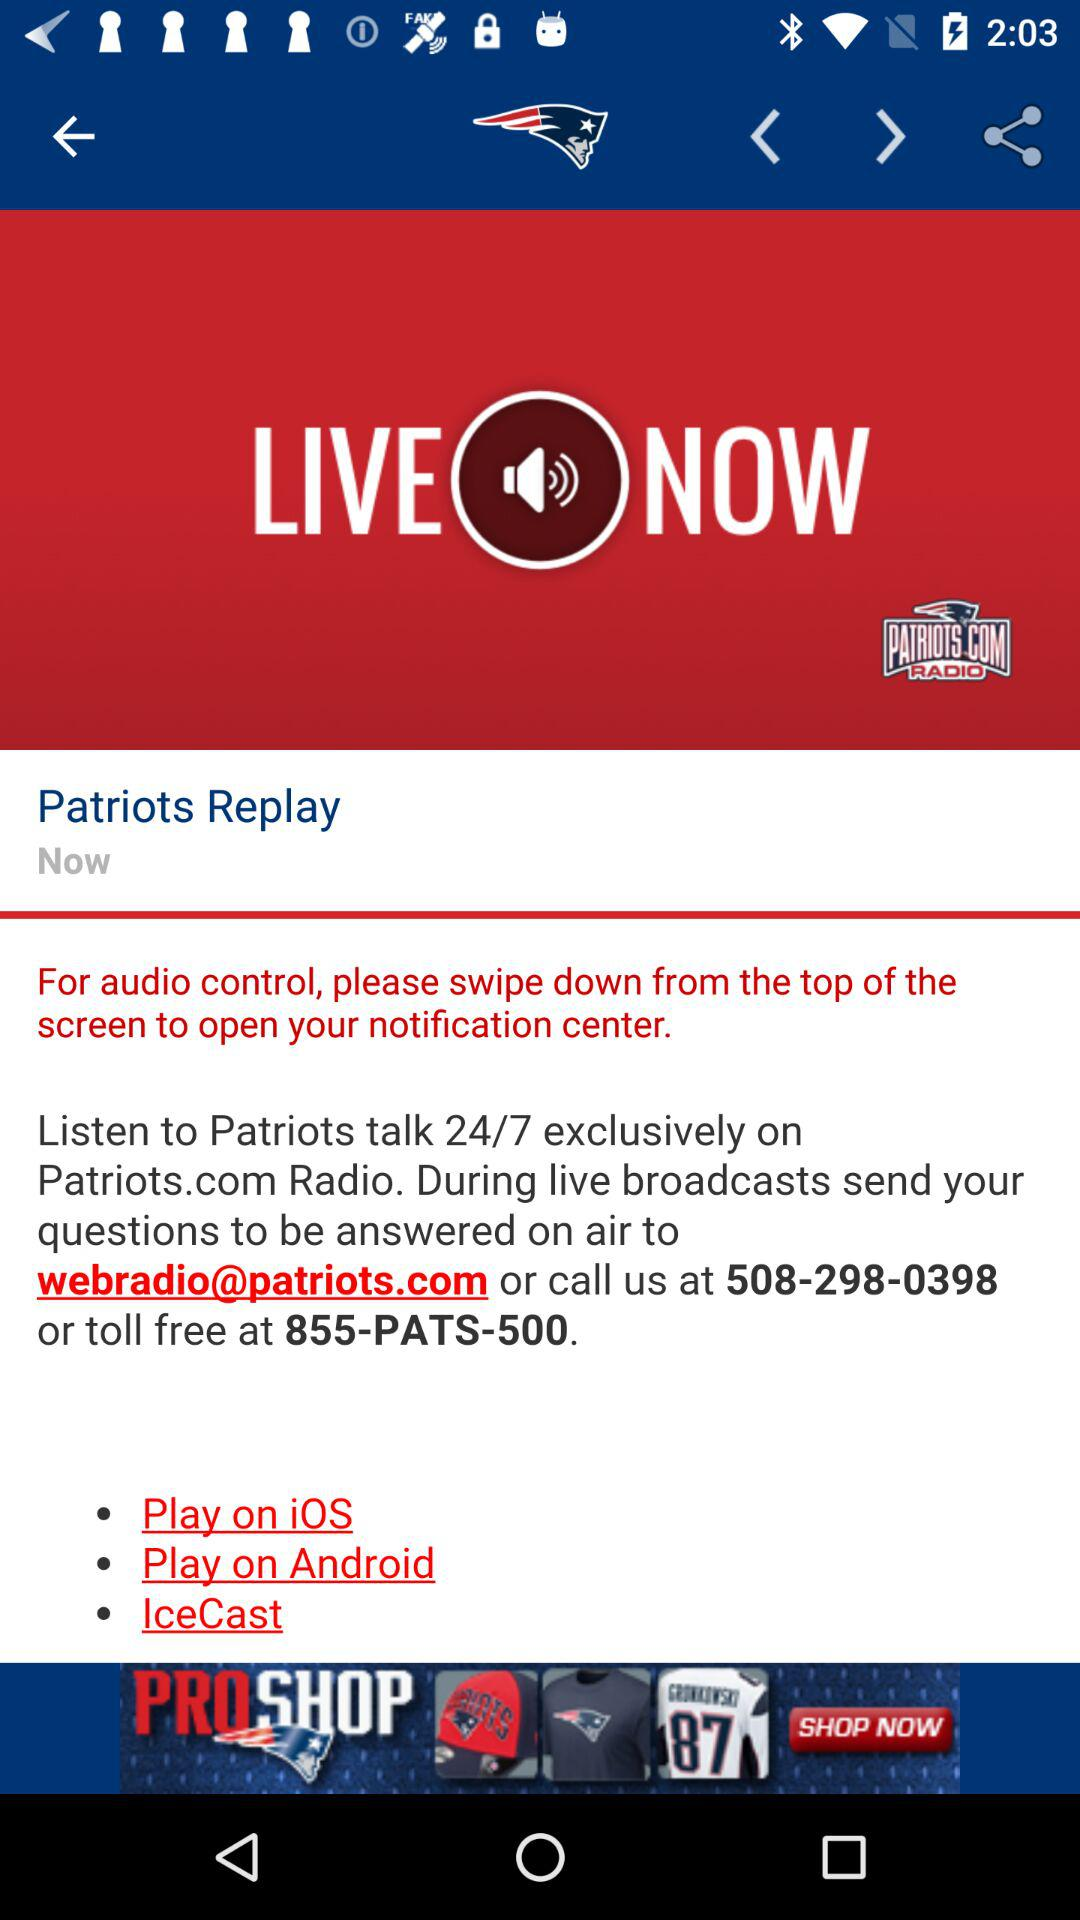What is the contact number? The contact numbers are 508-298-0398 and 855-PATS-500. 